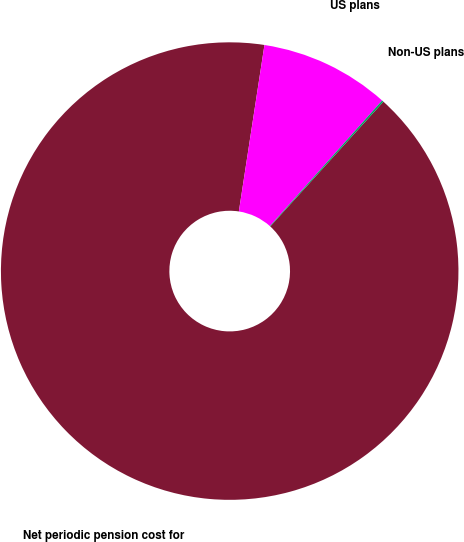<chart> <loc_0><loc_0><loc_500><loc_500><pie_chart><fcel>Net periodic pension cost for<fcel>US plans<fcel>Non-US plans<nl><fcel>90.71%<fcel>9.18%<fcel>0.12%<nl></chart> 